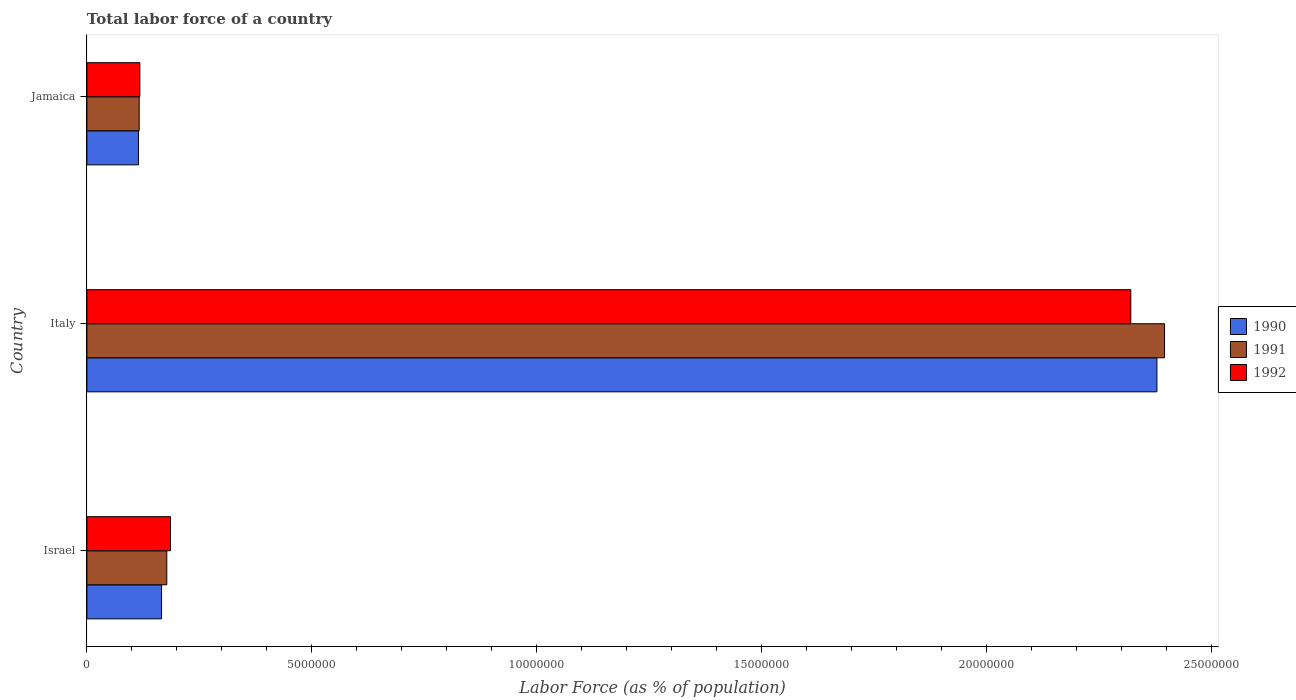Are the number of bars on each tick of the Y-axis equal?
Keep it short and to the point. Yes. How many bars are there on the 1st tick from the top?
Your answer should be compact. 3. How many bars are there on the 3rd tick from the bottom?
Offer a very short reply. 3. What is the label of the 1st group of bars from the top?
Keep it short and to the point. Jamaica. In how many cases, is the number of bars for a given country not equal to the number of legend labels?
Your answer should be very brief. 0. What is the percentage of labor force in 1992 in Israel?
Keep it short and to the point. 1.86e+06. Across all countries, what is the maximum percentage of labor force in 1992?
Your answer should be compact. 2.32e+07. Across all countries, what is the minimum percentage of labor force in 1990?
Offer a very short reply. 1.15e+06. In which country was the percentage of labor force in 1992 maximum?
Offer a very short reply. Italy. In which country was the percentage of labor force in 1992 minimum?
Your answer should be compact. Jamaica. What is the total percentage of labor force in 1992 in the graph?
Make the answer very short. 2.62e+07. What is the difference between the percentage of labor force in 1992 in Italy and that in Jamaica?
Your response must be concise. 2.20e+07. What is the difference between the percentage of labor force in 1991 in Italy and the percentage of labor force in 1992 in Jamaica?
Your response must be concise. 2.28e+07. What is the average percentage of labor force in 1992 per country?
Your answer should be compact. 8.75e+06. What is the difference between the percentage of labor force in 1991 and percentage of labor force in 1992 in Israel?
Keep it short and to the point. -8.20e+04. What is the ratio of the percentage of labor force in 1991 in Italy to that in Jamaica?
Your answer should be very brief. 20.6. Is the percentage of labor force in 1992 in Italy less than that in Jamaica?
Offer a terse response. No. What is the difference between the highest and the second highest percentage of labor force in 1992?
Offer a terse response. 2.13e+07. What is the difference between the highest and the lowest percentage of labor force in 1990?
Make the answer very short. 2.26e+07. In how many countries, is the percentage of labor force in 1992 greater than the average percentage of labor force in 1992 taken over all countries?
Ensure brevity in your answer.  1. Is the sum of the percentage of labor force in 1991 in Italy and Jamaica greater than the maximum percentage of labor force in 1990 across all countries?
Your answer should be compact. Yes. What does the 3rd bar from the top in Jamaica represents?
Ensure brevity in your answer.  1990. What does the 1st bar from the bottom in Jamaica represents?
Your answer should be very brief. 1990. Are all the bars in the graph horizontal?
Your response must be concise. Yes. How many countries are there in the graph?
Offer a terse response. 3. Are the values on the major ticks of X-axis written in scientific E-notation?
Provide a succinct answer. No. Does the graph contain any zero values?
Your answer should be very brief. No. Where does the legend appear in the graph?
Keep it short and to the point. Center right. How many legend labels are there?
Make the answer very short. 3. What is the title of the graph?
Keep it short and to the point. Total labor force of a country. Does "1976" appear as one of the legend labels in the graph?
Your response must be concise. No. What is the label or title of the X-axis?
Offer a very short reply. Labor Force (as % of population). What is the Labor Force (as % of population) of 1990 in Israel?
Your answer should be very brief. 1.66e+06. What is the Labor Force (as % of population) in 1991 in Israel?
Provide a short and direct response. 1.78e+06. What is the Labor Force (as % of population) in 1992 in Israel?
Offer a terse response. 1.86e+06. What is the Labor Force (as % of population) in 1990 in Italy?
Your answer should be very brief. 2.38e+07. What is the Labor Force (as % of population) in 1991 in Italy?
Your answer should be very brief. 2.40e+07. What is the Labor Force (as % of population) in 1992 in Italy?
Your answer should be compact. 2.32e+07. What is the Labor Force (as % of population) in 1990 in Jamaica?
Keep it short and to the point. 1.15e+06. What is the Labor Force (as % of population) in 1991 in Jamaica?
Provide a succinct answer. 1.16e+06. What is the Labor Force (as % of population) in 1992 in Jamaica?
Your response must be concise. 1.18e+06. Across all countries, what is the maximum Labor Force (as % of population) of 1990?
Offer a very short reply. 2.38e+07. Across all countries, what is the maximum Labor Force (as % of population) of 1991?
Your answer should be compact. 2.40e+07. Across all countries, what is the maximum Labor Force (as % of population) in 1992?
Provide a short and direct response. 2.32e+07. Across all countries, what is the minimum Labor Force (as % of population) in 1990?
Your answer should be compact. 1.15e+06. Across all countries, what is the minimum Labor Force (as % of population) of 1991?
Make the answer very short. 1.16e+06. Across all countries, what is the minimum Labor Force (as % of population) in 1992?
Your response must be concise. 1.18e+06. What is the total Labor Force (as % of population) in 1990 in the graph?
Provide a succinct answer. 2.66e+07. What is the total Labor Force (as % of population) of 1991 in the graph?
Your response must be concise. 2.69e+07. What is the total Labor Force (as % of population) in 1992 in the graph?
Your answer should be very brief. 2.62e+07. What is the difference between the Labor Force (as % of population) in 1990 in Israel and that in Italy?
Provide a succinct answer. -2.21e+07. What is the difference between the Labor Force (as % of population) of 1991 in Israel and that in Italy?
Give a very brief answer. -2.22e+07. What is the difference between the Labor Force (as % of population) in 1992 in Israel and that in Italy?
Keep it short and to the point. -2.13e+07. What is the difference between the Labor Force (as % of population) of 1990 in Israel and that in Jamaica?
Ensure brevity in your answer.  5.13e+05. What is the difference between the Labor Force (as % of population) of 1991 in Israel and that in Jamaica?
Offer a terse response. 6.14e+05. What is the difference between the Labor Force (as % of population) in 1992 in Israel and that in Jamaica?
Your answer should be compact. 6.81e+05. What is the difference between the Labor Force (as % of population) in 1990 in Italy and that in Jamaica?
Keep it short and to the point. 2.26e+07. What is the difference between the Labor Force (as % of population) in 1991 in Italy and that in Jamaica?
Offer a terse response. 2.28e+07. What is the difference between the Labor Force (as % of population) of 1992 in Italy and that in Jamaica?
Your answer should be very brief. 2.20e+07. What is the difference between the Labor Force (as % of population) in 1990 in Israel and the Labor Force (as % of population) in 1991 in Italy?
Give a very brief answer. -2.23e+07. What is the difference between the Labor Force (as % of population) of 1990 in Israel and the Labor Force (as % of population) of 1992 in Italy?
Give a very brief answer. -2.15e+07. What is the difference between the Labor Force (as % of population) of 1991 in Israel and the Labor Force (as % of population) of 1992 in Italy?
Your answer should be compact. -2.14e+07. What is the difference between the Labor Force (as % of population) in 1990 in Israel and the Labor Force (as % of population) in 1991 in Jamaica?
Offer a very short reply. 4.97e+05. What is the difference between the Labor Force (as % of population) in 1990 in Israel and the Labor Force (as % of population) in 1992 in Jamaica?
Offer a very short reply. 4.82e+05. What is the difference between the Labor Force (as % of population) of 1991 in Israel and the Labor Force (as % of population) of 1992 in Jamaica?
Your answer should be compact. 5.99e+05. What is the difference between the Labor Force (as % of population) of 1990 in Italy and the Labor Force (as % of population) of 1991 in Jamaica?
Your answer should be compact. 2.26e+07. What is the difference between the Labor Force (as % of population) of 1990 in Italy and the Labor Force (as % of population) of 1992 in Jamaica?
Provide a succinct answer. 2.26e+07. What is the difference between the Labor Force (as % of population) of 1991 in Italy and the Labor Force (as % of population) of 1992 in Jamaica?
Keep it short and to the point. 2.28e+07. What is the average Labor Force (as % of population) of 1990 per country?
Keep it short and to the point. 8.86e+06. What is the average Labor Force (as % of population) in 1991 per country?
Keep it short and to the point. 8.96e+06. What is the average Labor Force (as % of population) of 1992 per country?
Your response must be concise. 8.75e+06. What is the difference between the Labor Force (as % of population) in 1990 and Labor Force (as % of population) in 1991 in Israel?
Your response must be concise. -1.17e+05. What is the difference between the Labor Force (as % of population) of 1990 and Labor Force (as % of population) of 1992 in Israel?
Ensure brevity in your answer.  -1.99e+05. What is the difference between the Labor Force (as % of population) of 1991 and Labor Force (as % of population) of 1992 in Israel?
Give a very brief answer. -8.20e+04. What is the difference between the Labor Force (as % of population) of 1990 and Labor Force (as % of population) of 1991 in Italy?
Provide a short and direct response. -1.70e+05. What is the difference between the Labor Force (as % of population) in 1990 and Labor Force (as % of population) in 1992 in Italy?
Provide a short and direct response. 5.81e+05. What is the difference between the Labor Force (as % of population) of 1991 and Labor Force (as % of population) of 1992 in Italy?
Your answer should be very brief. 7.51e+05. What is the difference between the Labor Force (as % of population) in 1990 and Labor Force (as % of population) in 1991 in Jamaica?
Offer a very short reply. -1.61e+04. What is the difference between the Labor Force (as % of population) of 1990 and Labor Force (as % of population) of 1992 in Jamaica?
Provide a short and direct response. -3.05e+04. What is the difference between the Labor Force (as % of population) of 1991 and Labor Force (as % of population) of 1992 in Jamaica?
Your answer should be very brief. -1.44e+04. What is the ratio of the Labor Force (as % of population) in 1990 in Israel to that in Italy?
Make the answer very short. 0.07. What is the ratio of the Labor Force (as % of population) of 1991 in Israel to that in Italy?
Make the answer very short. 0.07. What is the ratio of the Labor Force (as % of population) of 1992 in Israel to that in Italy?
Your response must be concise. 0.08. What is the ratio of the Labor Force (as % of population) of 1990 in Israel to that in Jamaica?
Your answer should be very brief. 1.45. What is the ratio of the Labor Force (as % of population) in 1991 in Israel to that in Jamaica?
Offer a terse response. 1.53. What is the ratio of the Labor Force (as % of population) of 1992 in Israel to that in Jamaica?
Offer a terse response. 1.58. What is the ratio of the Labor Force (as % of population) of 1990 in Italy to that in Jamaica?
Offer a very short reply. 20.74. What is the ratio of the Labor Force (as % of population) in 1991 in Italy to that in Jamaica?
Provide a short and direct response. 20.6. What is the ratio of the Labor Force (as % of population) in 1992 in Italy to that in Jamaica?
Your response must be concise. 19.71. What is the difference between the highest and the second highest Labor Force (as % of population) in 1990?
Offer a terse response. 2.21e+07. What is the difference between the highest and the second highest Labor Force (as % of population) in 1991?
Make the answer very short. 2.22e+07. What is the difference between the highest and the second highest Labor Force (as % of population) in 1992?
Offer a terse response. 2.13e+07. What is the difference between the highest and the lowest Labor Force (as % of population) of 1990?
Ensure brevity in your answer.  2.26e+07. What is the difference between the highest and the lowest Labor Force (as % of population) in 1991?
Your response must be concise. 2.28e+07. What is the difference between the highest and the lowest Labor Force (as % of population) of 1992?
Make the answer very short. 2.20e+07. 